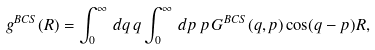Convert formula to latex. <formula><loc_0><loc_0><loc_500><loc_500>g ^ { B C S } ( R ) = \int _ { 0 } ^ { \infty } \, d q \, q \int _ { 0 } ^ { \infty } \, d p \, p \, G ^ { B C S } ( q , p ) \cos ( q - p ) R ,</formula> 